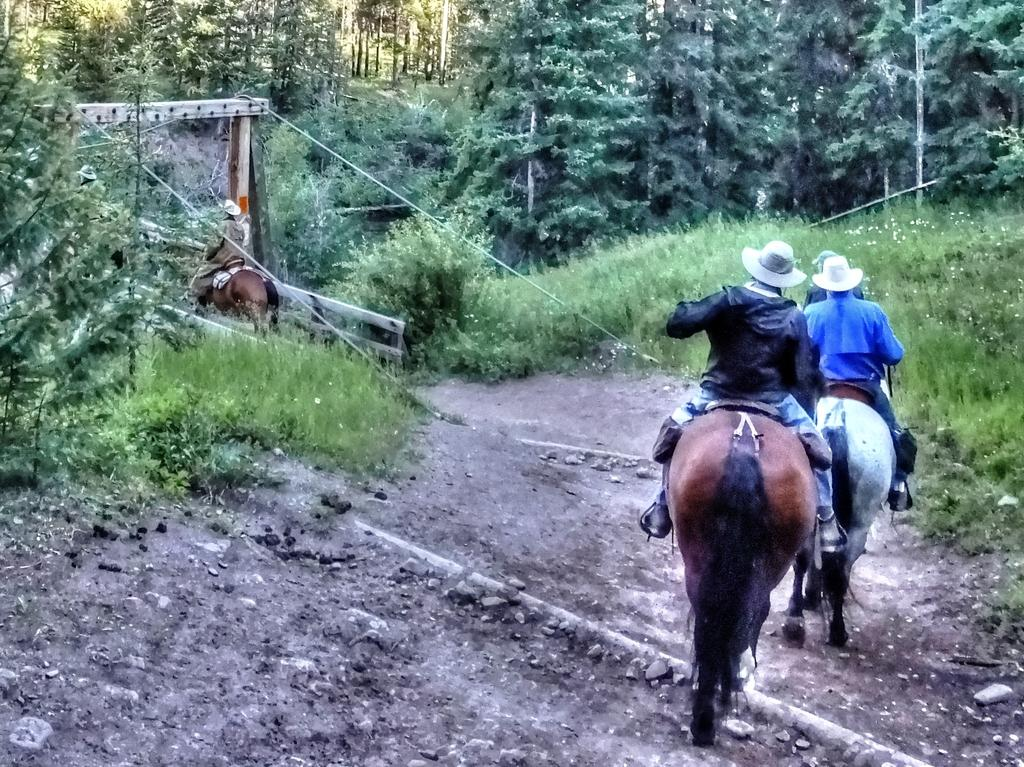What are the people in the image doing? The people in the image are sitting on horses. What are the people wearing on their heads? The people are wearing hats. What can be seen in the background of the image? There are trees and grass in the background of the image. What type of chain is being used to secure the horses in the image? There is no chain visible in the image; the horses are not secured with a chain. 